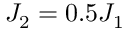Convert formula to latex. <formula><loc_0><loc_0><loc_500><loc_500>J _ { 2 } = 0 . 5 J _ { 1 }</formula> 